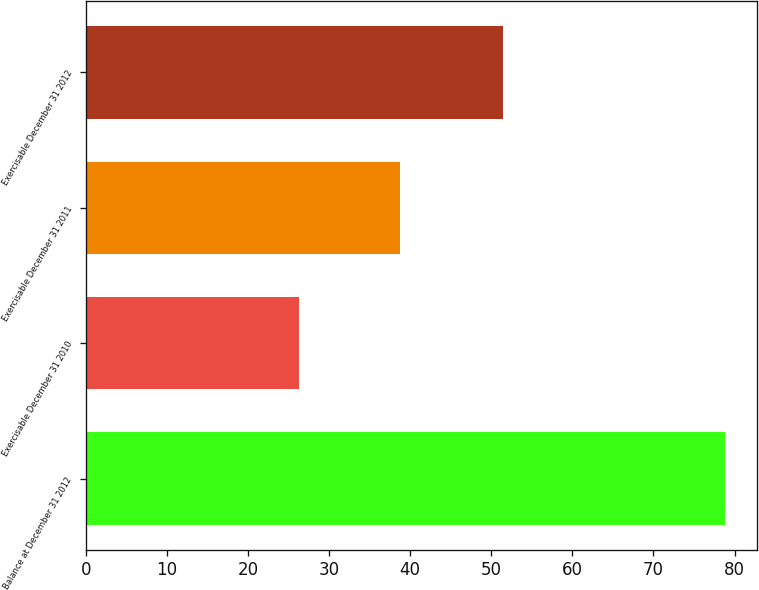Convert chart to OTSL. <chart><loc_0><loc_0><loc_500><loc_500><bar_chart><fcel>Balance at December 31 2012<fcel>Exercisable December 31 2010<fcel>Exercisable December 31 2011<fcel>Exercisable December 31 2012<nl><fcel>78.8<fcel>26.36<fcel>38.75<fcel>51.4<nl></chart> 